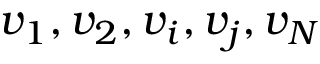<formula> <loc_0><loc_0><loc_500><loc_500>v _ { 1 } , v _ { 2 } , v _ { i } , v _ { j } , v _ { N }</formula> 